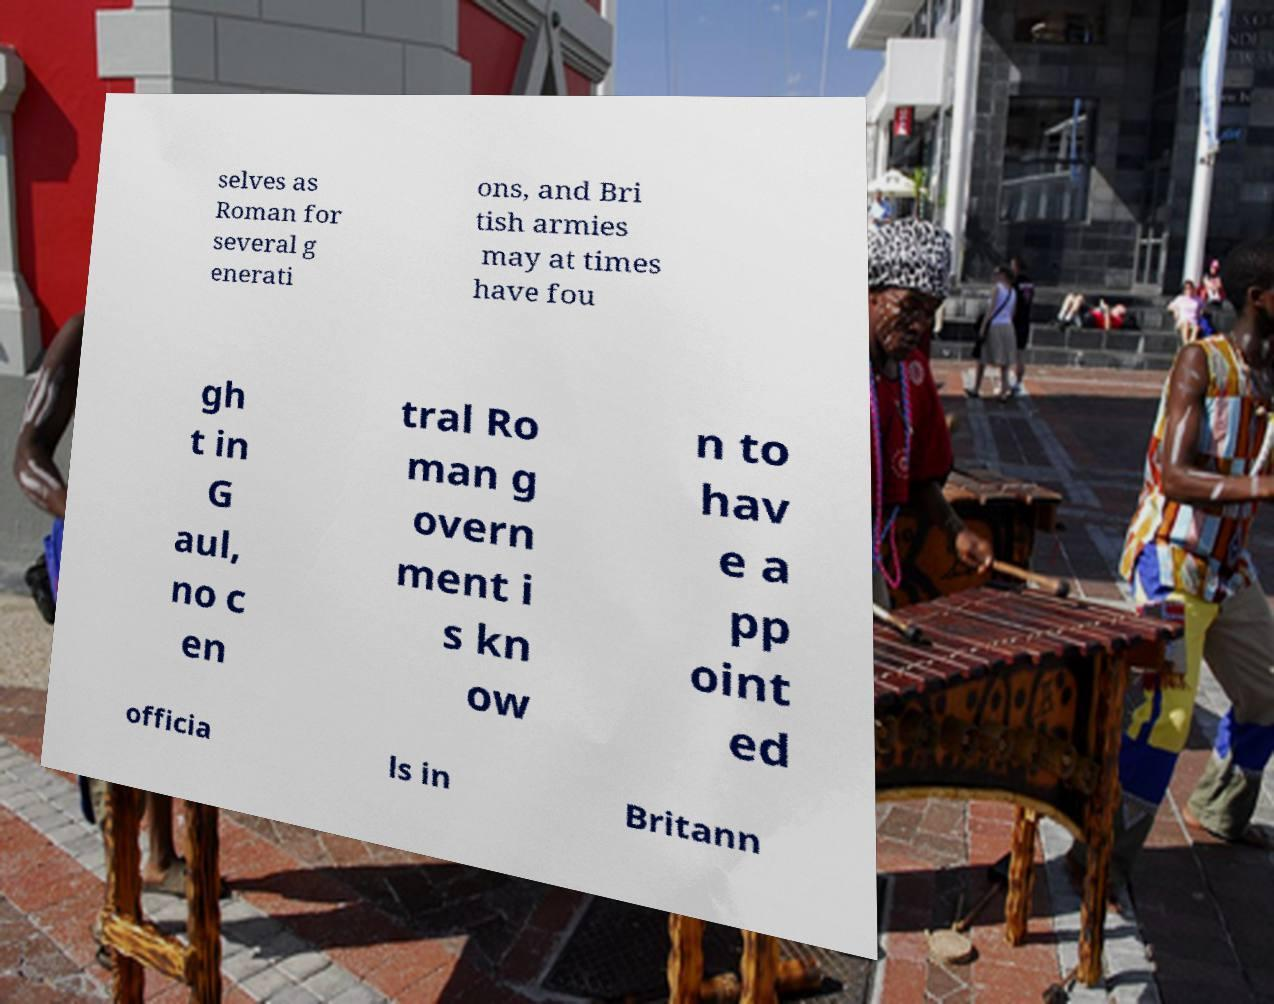Can you read and provide the text displayed in the image?This photo seems to have some interesting text. Can you extract and type it out for me? selves as Roman for several g enerati ons, and Bri tish armies may at times have fou gh t in G aul, no c en tral Ro man g overn ment i s kn ow n to hav e a pp oint ed officia ls in Britann 